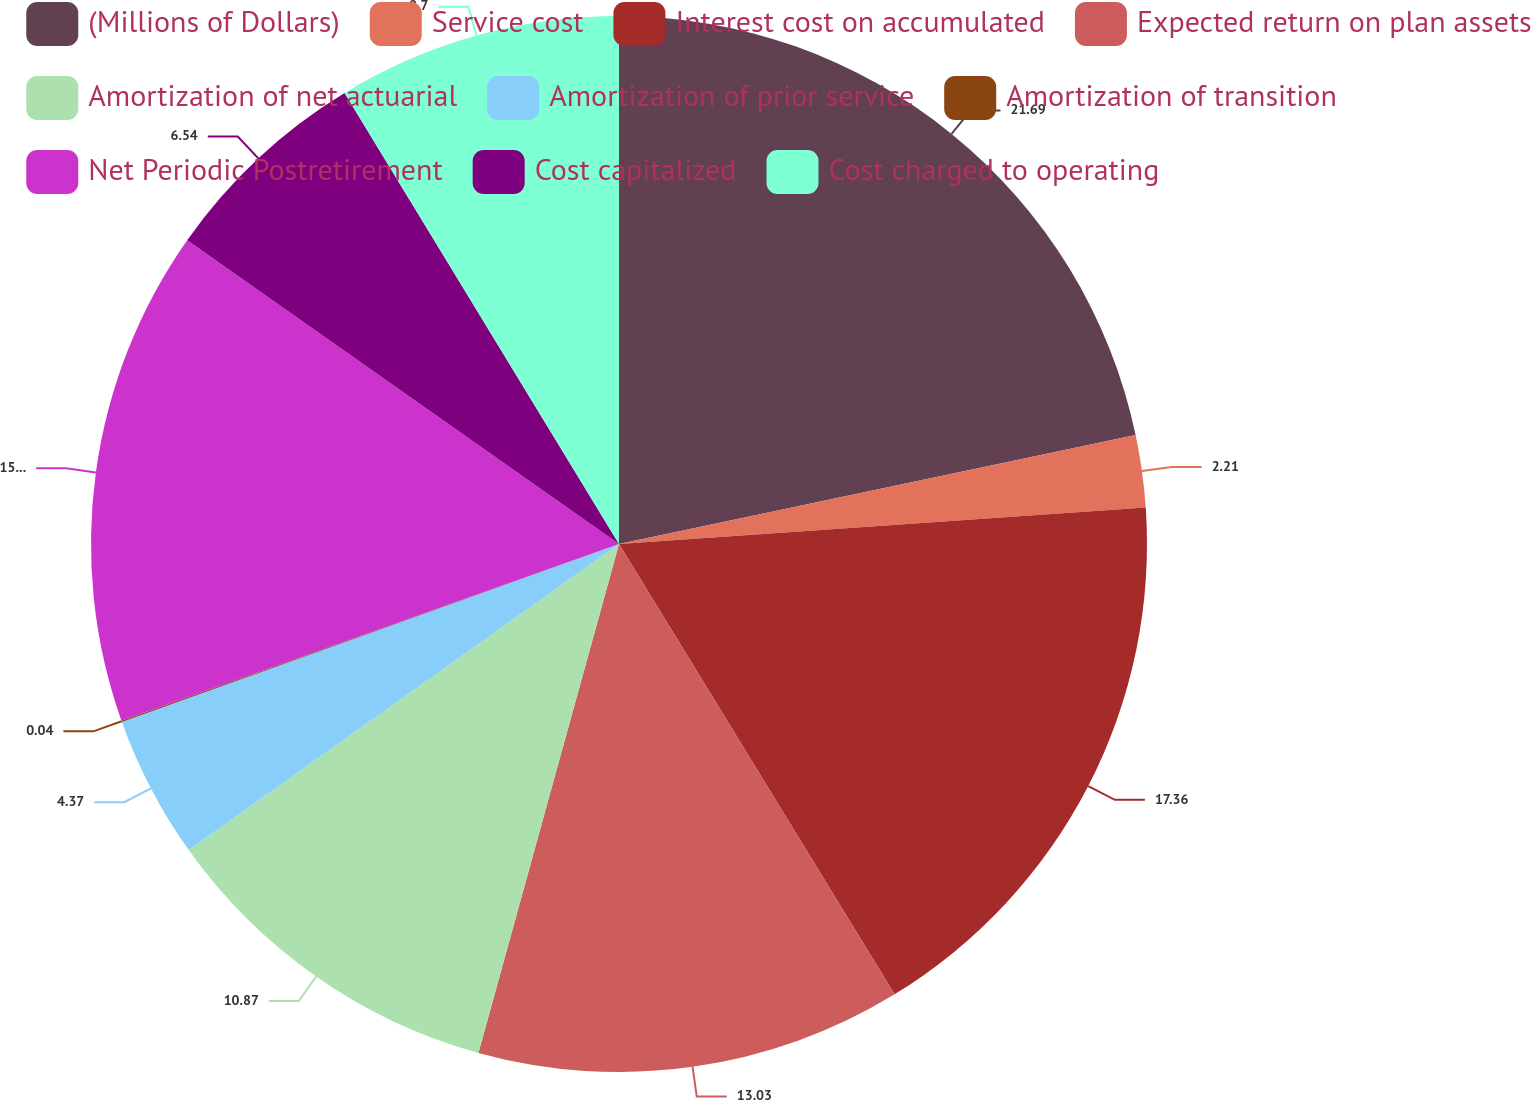<chart> <loc_0><loc_0><loc_500><loc_500><pie_chart><fcel>(Millions of Dollars)<fcel>Service cost<fcel>Interest cost on accumulated<fcel>Expected return on plan assets<fcel>Amortization of net actuarial<fcel>Amortization of prior service<fcel>Amortization of transition<fcel>Net Periodic Postretirement<fcel>Cost capitalized<fcel>Cost charged to operating<nl><fcel>21.69%<fcel>2.21%<fcel>17.36%<fcel>13.03%<fcel>10.87%<fcel>4.37%<fcel>0.04%<fcel>15.19%<fcel>6.54%<fcel>8.7%<nl></chart> 